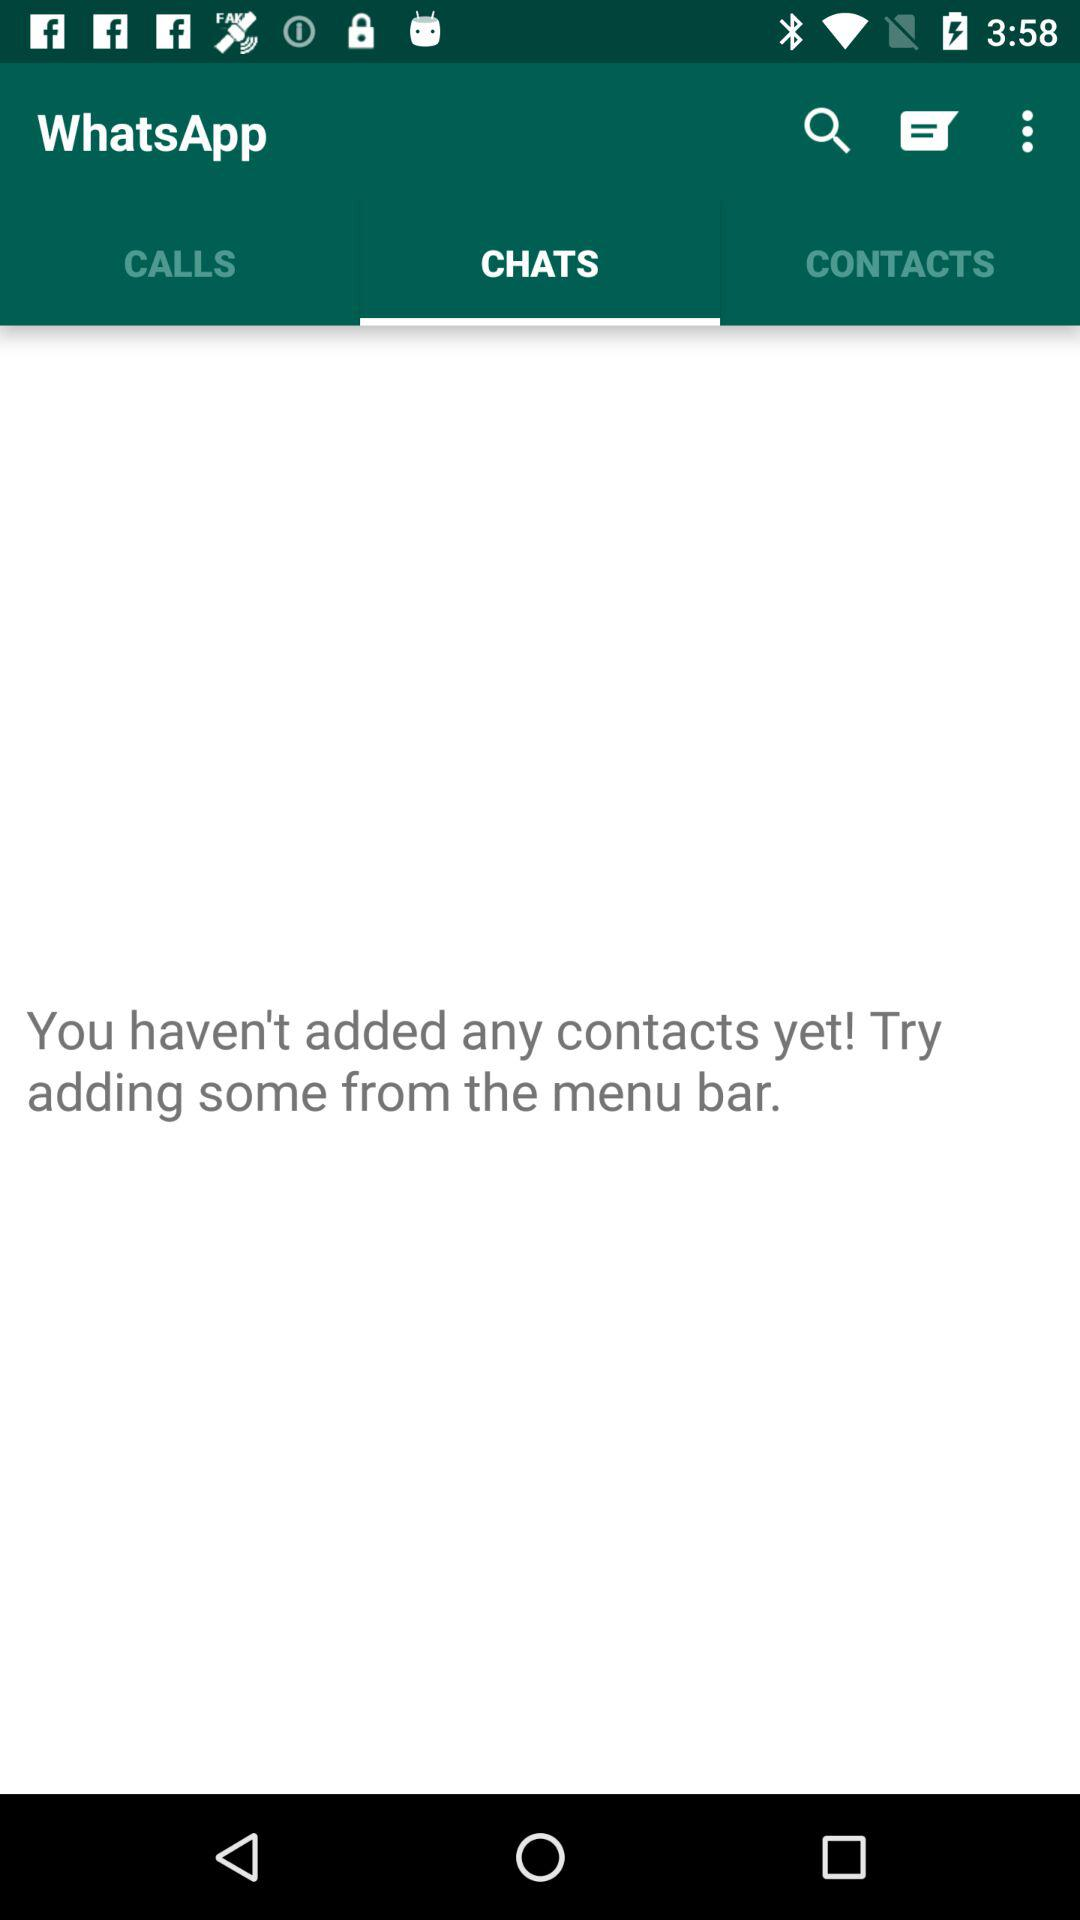How many sentences are in the disclaimer?
Answer the question using a single word or phrase. 3 